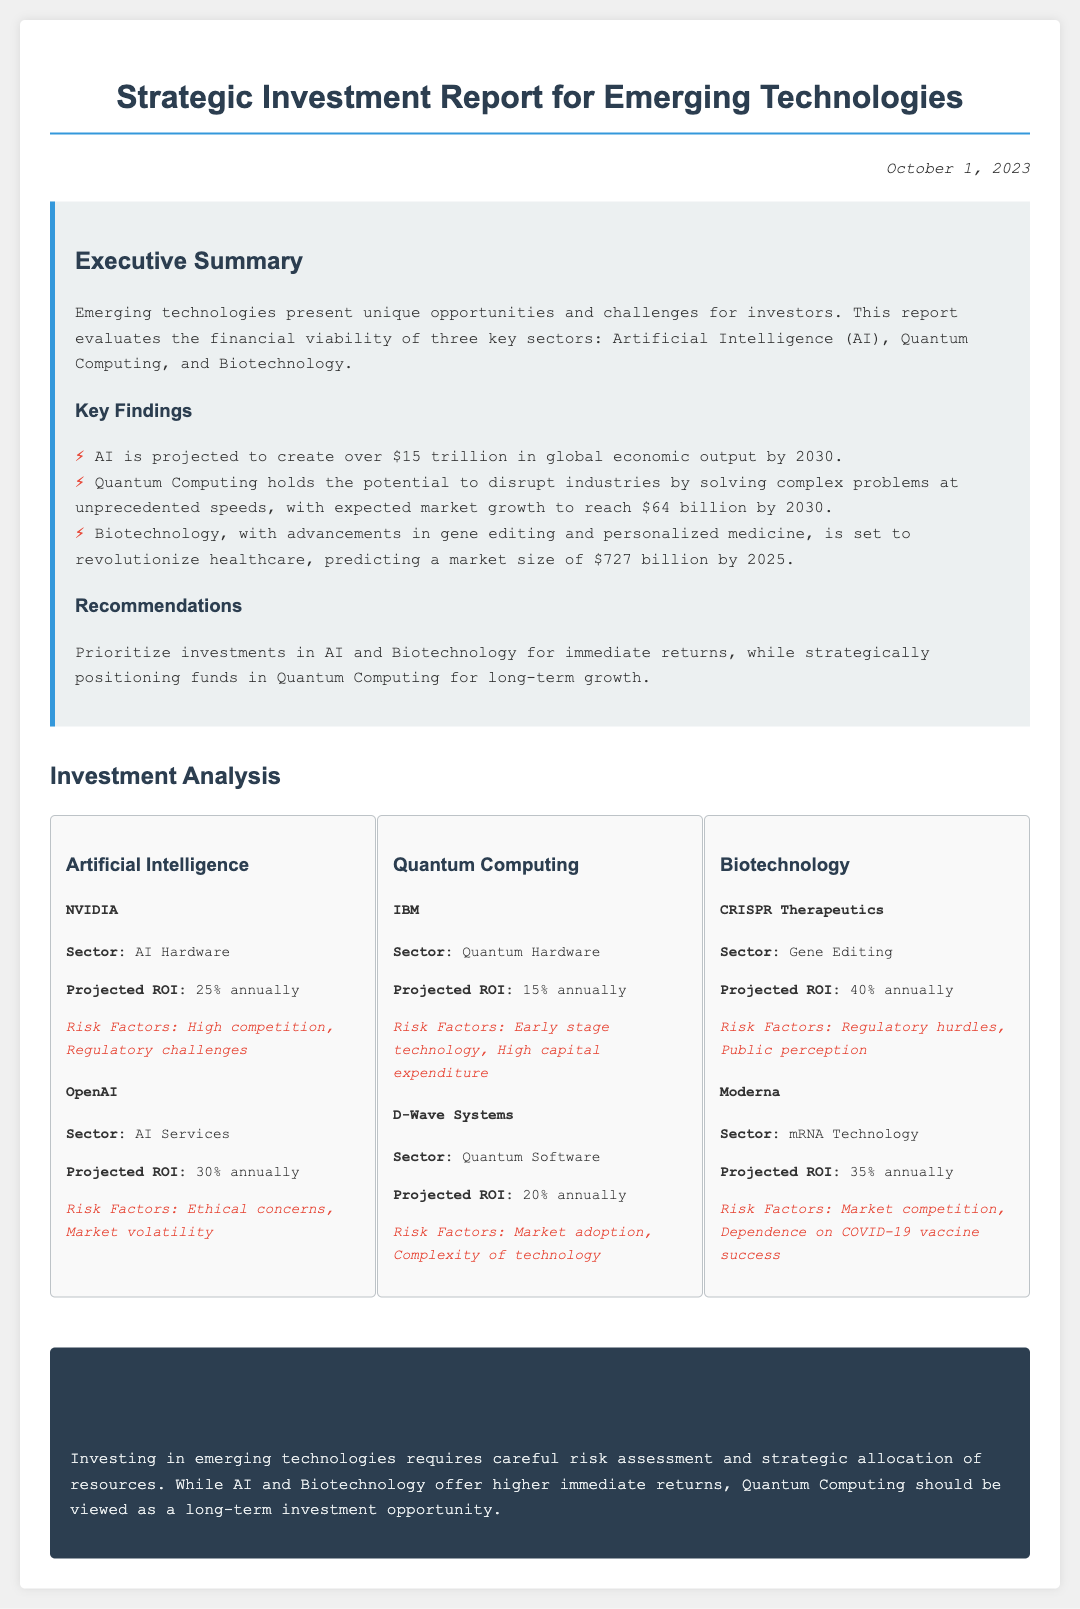what is the projected market size for Quantum Computing by 2030? The projected market size for Quantum Computing is mentioned as reaching $64 billion by 2030.
Answer: $64 billion what is the projected ROI for CRISPR Therapeutics? The projected ROI for CRISPR Therapeutics is specified as 40% annually.
Answer: 40% which sector has the highest projected ROI? The document lists CRISPR Therapeutics in Biotechnology with the highest projected ROI of 40% annually.
Answer: Biotechnology what is the recommended investment strategy for Quantum Computing? The recommendations state that funds should be strategically positioned in Quantum Computing for long-term growth.
Answer: Long-term growth which company operates in the AI Services sector? OpenAI is identified as the company operating in the AI Services sector.
Answer: OpenAI what are the main risk factors for NVIDIA? The risk factors listed for NVIDIA include high competition and regulatory challenges.
Answer: High competition, Regulatory challenges what is the market size prediction for Biotechnology by 2025? The document predicts the market size for Biotechnology to be $727 billion by 2025.
Answer: $727 billion what are the risk factors for D-Wave Systems? The risk factors for D-Wave Systems include market adoption and complexity of technology.
Answer: Market adoption, Complexity of technology 